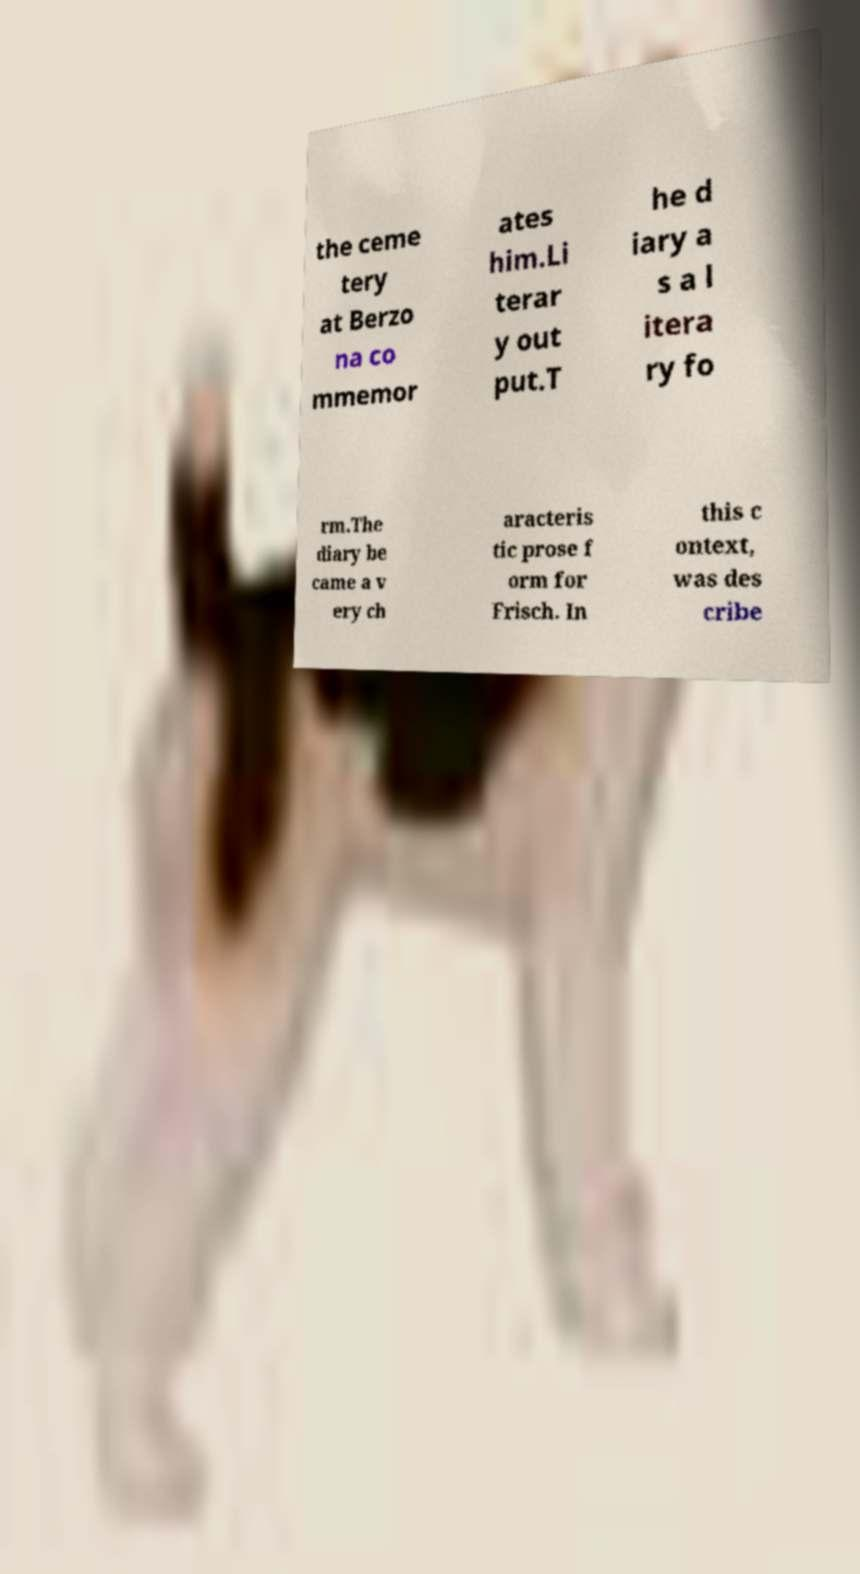Please read and relay the text visible in this image. What does it say? the ceme tery at Berzo na co mmemor ates him.Li terar y out put.T he d iary a s a l itera ry fo rm.The diary be came a v ery ch aracteris tic prose f orm for Frisch. In this c ontext, was des cribe 